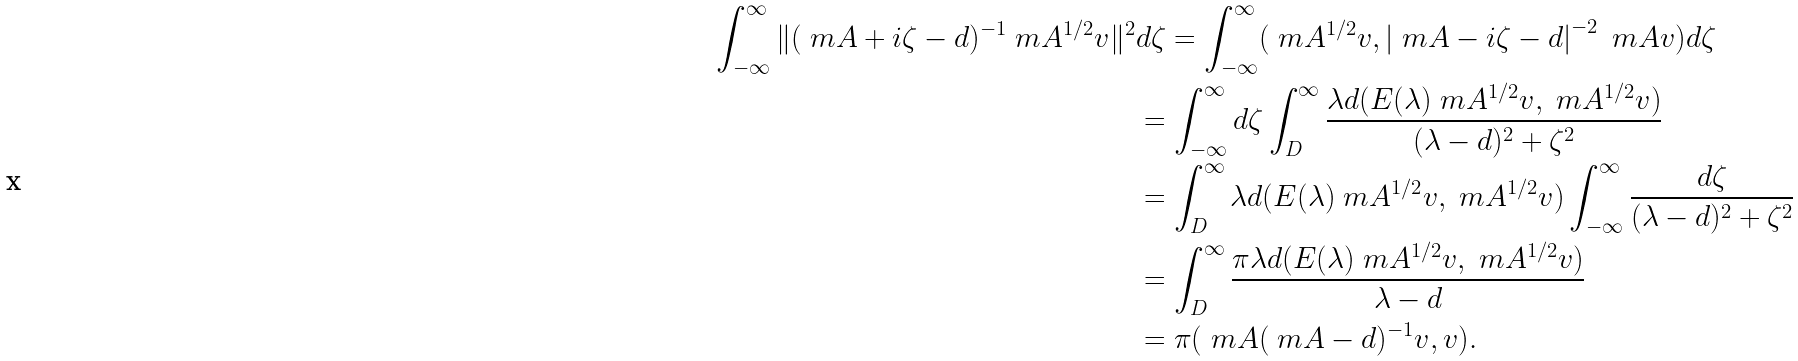Convert formula to latex. <formula><loc_0><loc_0><loc_500><loc_500>\int ^ { \infty } _ { - \infty } \| ( \ m A + i \zeta - d ) ^ { - 1 } \ m A ^ { 1 / 2 } v \| ^ { 2 } & d \zeta = \int ^ { \infty } _ { - \infty } ( \ m A ^ { 1 / 2 } v , \left | \ m A - i \zeta - d \right | ^ { - 2 } \ m A v ) d \zeta \\ & = \int ^ { \infty } _ { - \infty } d \zeta \int _ { D } ^ { \infty } \frac { \lambda d ( E ( \lambda ) \ m A ^ { 1 / 2 } v , \ m A ^ { 1 / 2 } v ) } { ( \lambda - d ) ^ { 2 } + \zeta ^ { 2 } } \\ & = \int _ { D } ^ { \infty } \lambda d ( E ( \lambda ) \ m A ^ { 1 / 2 } v , \ m A ^ { 1 / 2 } v ) \int ^ { \infty } _ { - \infty } \frac { d \zeta } { ( \lambda - d ) ^ { 2 } + \zeta ^ { 2 } } \\ & = \int ^ { \infty } _ { D } \frac { \pi \lambda d ( E ( \lambda ) \ m A ^ { 1 / 2 } v , \ m A ^ { 1 / 2 } v ) } { \lambda - d } \\ & = \pi ( \ m A ( \ m A - d ) ^ { - 1 } v , v ) .</formula> 